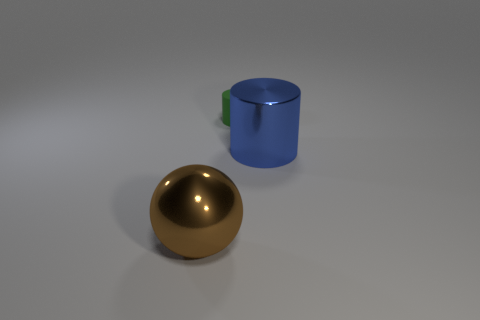Add 1 large metallic balls. How many objects exist? 4 Subtract all spheres. How many objects are left? 2 Add 3 matte things. How many matte things exist? 4 Subtract 0 blue balls. How many objects are left? 3 Subtract all big metallic cylinders. Subtract all cyan things. How many objects are left? 2 Add 3 brown things. How many brown things are left? 4 